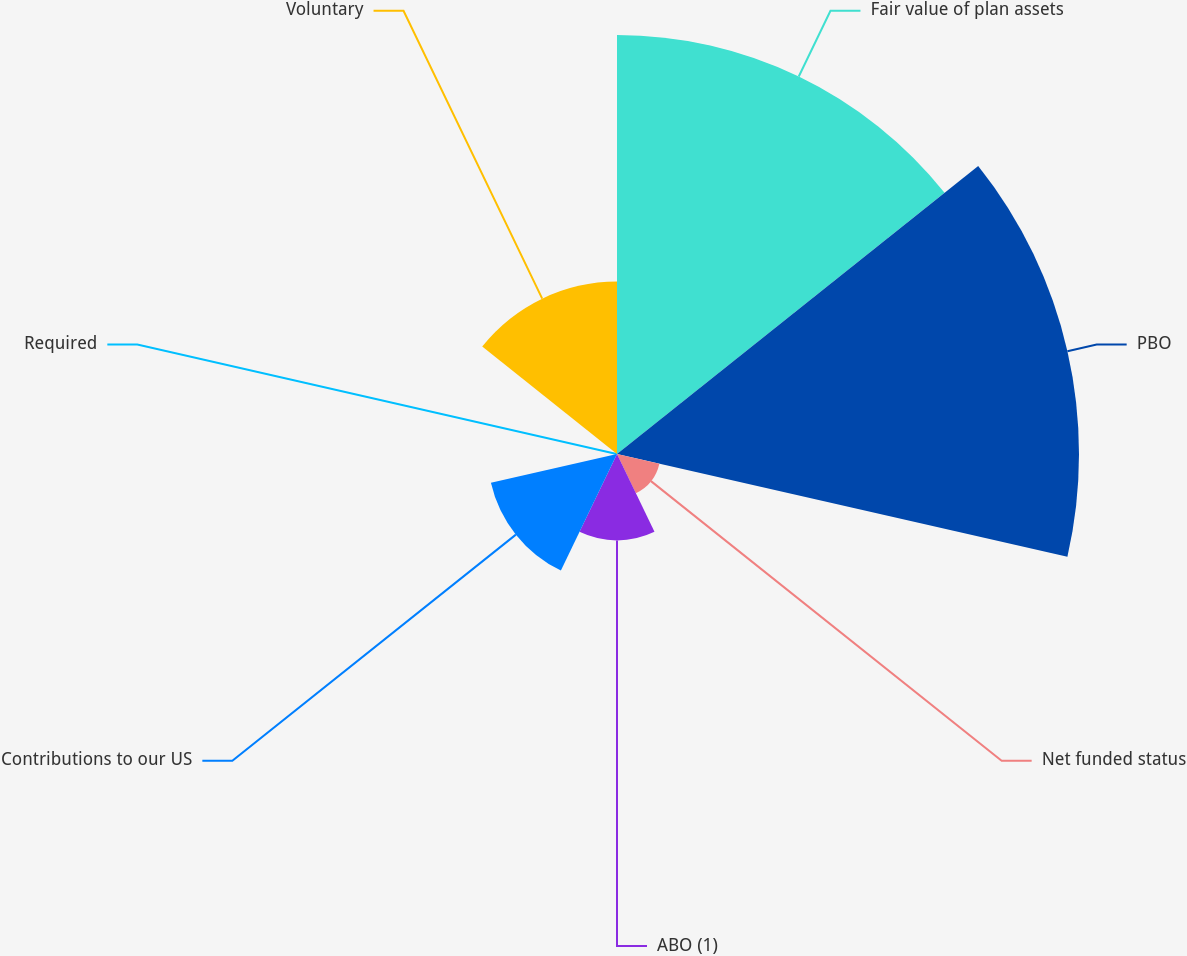Convert chart to OTSL. <chart><loc_0><loc_0><loc_500><loc_500><pie_chart><fcel>Fair value of plan assets<fcel>PBO<fcel>Net funded status<fcel>ABO (1)<fcel>Contributions to our US<fcel>Required<fcel>Voluntary<nl><fcel>31.91%<fcel>35.19%<fcel>3.31%<fcel>6.58%<fcel>9.85%<fcel>0.03%<fcel>13.13%<nl></chart> 